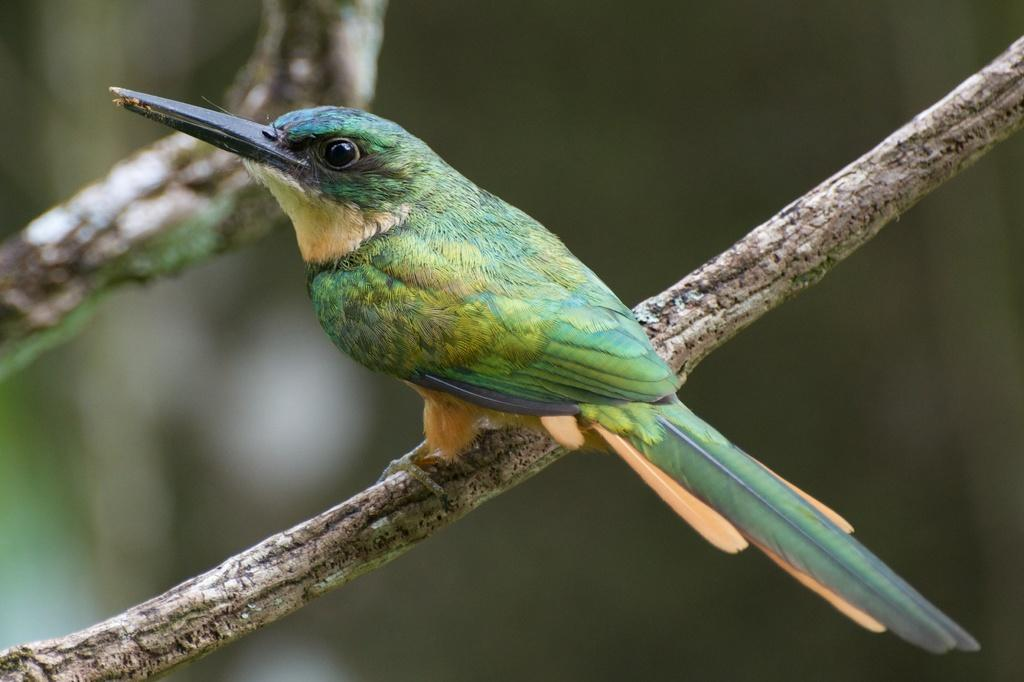What type of animal can be seen in the image? There is a bird in the image. Where is the bird located in the image? The bird is sitting on a branch of a tree. What else can be seen in the image besides the bird? There are branches of a tree visible in the image. How would you describe the background of the image? The background of the image is blurred. What type of fruit is the bird producing in the image? There is no fruit production depicted in the image, as it features a bird sitting on a branch of a tree. 